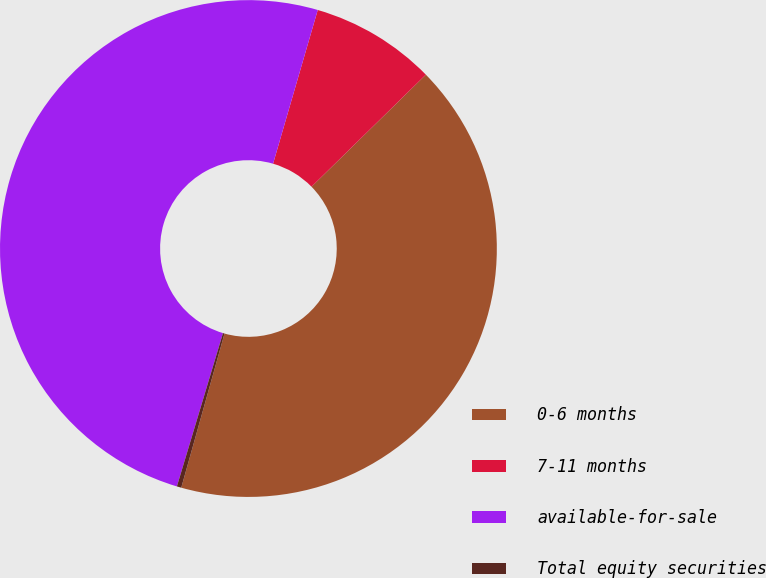<chart> <loc_0><loc_0><loc_500><loc_500><pie_chart><fcel>0-6 months<fcel>7-11 months<fcel>available-for-sale<fcel>Total equity securities<nl><fcel>41.69%<fcel>8.16%<fcel>49.85%<fcel>0.29%<nl></chart> 